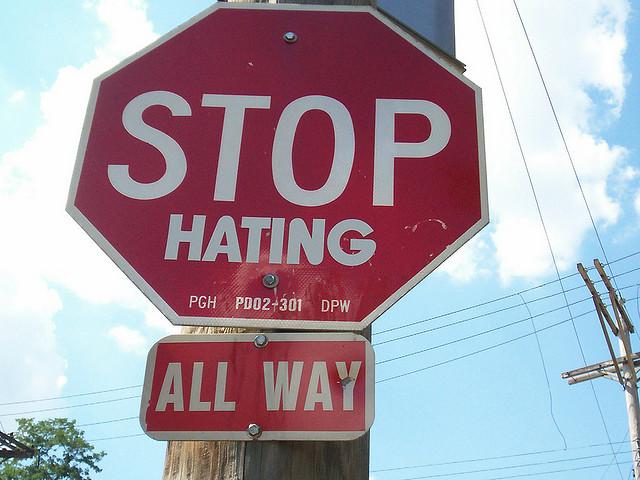What color is the sign?
Answer briefly. Red. How many electrical lines are behind the sign?
Be succinct. 9. Was this stop sign altered?
Quick response, please. Yes. What time is it according to the sign?
Concise answer only. Hate time. What is the sign saying?
Short answer required. Stop hating. What does the second sign say?
Give a very brief answer. All way. Is the word hating spelled correctly?
Concise answer only. Yes. 